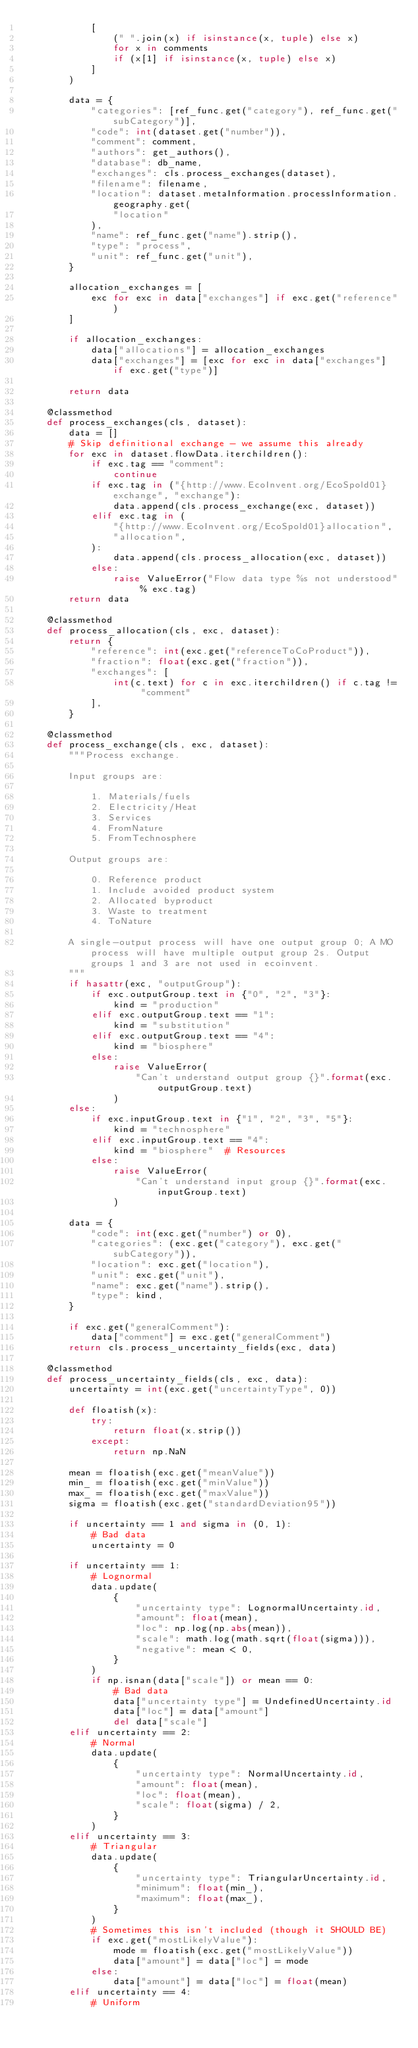Convert code to text. <code><loc_0><loc_0><loc_500><loc_500><_Python_>            [
                (" ".join(x) if isinstance(x, tuple) else x)
                for x in comments
                if (x[1] if isinstance(x, tuple) else x)
            ]
        )

        data = {
            "categories": [ref_func.get("category"), ref_func.get("subCategory")],
            "code": int(dataset.get("number")),
            "comment": comment,
            "authors": get_authors(),
            "database": db_name,
            "exchanges": cls.process_exchanges(dataset),
            "filename": filename,
            "location": dataset.metaInformation.processInformation.geography.get(
                "location"
            ),
            "name": ref_func.get("name").strip(),
            "type": "process",
            "unit": ref_func.get("unit"),
        }

        allocation_exchanges = [
            exc for exc in data["exchanges"] if exc.get("reference")
        ]

        if allocation_exchanges:
            data["allocations"] = allocation_exchanges
            data["exchanges"] = [exc for exc in data["exchanges"] if exc.get("type")]

        return data

    @classmethod
    def process_exchanges(cls, dataset):
        data = []
        # Skip definitional exchange - we assume this already
        for exc in dataset.flowData.iterchildren():
            if exc.tag == "comment":
                continue
            if exc.tag in ("{http://www.EcoInvent.org/EcoSpold01}exchange", "exchange"):
                data.append(cls.process_exchange(exc, dataset))
            elif exc.tag in (
                "{http://www.EcoInvent.org/EcoSpold01}allocation",
                "allocation",
            ):
                data.append(cls.process_allocation(exc, dataset))
            else:
                raise ValueError("Flow data type %s not understood" % exc.tag)
        return data

    @classmethod
    def process_allocation(cls, exc, dataset):
        return {
            "reference": int(exc.get("referenceToCoProduct")),
            "fraction": float(exc.get("fraction")),
            "exchanges": [
                int(c.text) for c in exc.iterchildren() if c.tag != "comment"
            ],
        }

    @classmethod
    def process_exchange(cls, exc, dataset):
        """Process exchange.

        Input groups are:

            1. Materials/fuels
            2. Electricity/Heat
            3. Services
            4. FromNature
            5. FromTechnosphere

        Output groups are:

            0. Reference product
            1. Include avoided product system
            2. Allocated byproduct
            3. Waste to treatment
            4. ToNature

        A single-output process will have one output group 0; A MO process will have multiple output group 2s. Output groups 1 and 3 are not used in ecoinvent.
        """
        if hasattr(exc, "outputGroup"):
            if exc.outputGroup.text in {"0", "2", "3"}:
                kind = "production"
            elif exc.outputGroup.text == "1":
                kind = "substitution"
            elif exc.outputGroup.text == "4":
                kind = "biosphere"
            else:
                raise ValueError(
                    "Can't understand output group {}".format(exc.outputGroup.text)
                )
        else:
            if exc.inputGroup.text in {"1", "2", "3", "5"}:
                kind = "technosphere"
            elif exc.inputGroup.text == "4":
                kind = "biosphere"  # Resources
            else:
                raise ValueError(
                    "Can't understand input group {}".format(exc.inputGroup.text)
                )

        data = {
            "code": int(exc.get("number") or 0),
            "categories": (exc.get("category"), exc.get("subCategory")),
            "location": exc.get("location"),
            "unit": exc.get("unit"),
            "name": exc.get("name").strip(),
            "type": kind,
        }

        if exc.get("generalComment"):
            data["comment"] = exc.get("generalComment")
        return cls.process_uncertainty_fields(exc, data)

    @classmethod
    def process_uncertainty_fields(cls, exc, data):
        uncertainty = int(exc.get("uncertaintyType", 0))

        def floatish(x):
            try:
                return float(x.strip())
            except:
                return np.NaN

        mean = floatish(exc.get("meanValue"))
        min_ = floatish(exc.get("minValue"))
        max_ = floatish(exc.get("maxValue"))
        sigma = floatish(exc.get("standardDeviation95"))

        if uncertainty == 1 and sigma in (0, 1):
            # Bad data
            uncertainty = 0

        if uncertainty == 1:
            # Lognormal
            data.update(
                {
                    "uncertainty type": LognormalUncertainty.id,
                    "amount": float(mean),
                    "loc": np.log(np.abs(mean)),
                    "scale": math.log(math.sqrt(float(sigma))),
                    "negative": mean < 0,
                }
            )
            if np.isnan(data["scale"]) or mean == 0:
                # Bad data
                data["uncertainty type"] = UndefinedUncertainty.id
                data["loc"] = data["amount"]
                del data["scale"]
        elif uncertainty == 2:
            # Normal
            data.update(
                {
                    "uncertainty type": NormalUncertainty.id,
                    "amount": float(mean),
                    "loc": float(mean),
                    "scale": float(sigma) / 2,
                }
            )
        elif uncertainty == 3:
            # Triangular
            data.update(
                {
                    "uncertainty type": TriangularUncertainty.id,
                    "minimum": float(min_),
                    "maximum": float(max_),
                }
            )
            # Sometimes this isn't included (though it SHOULD BE)
            if exc.get("mostLikelyValue"):
                mode = floatish(exc.get("mostLikelyValue"))
                data["amount"] = data["loc"] = mode
            else:
                data["amount"] = data["loc"] = float(mean)
        elif uncertainty == 4:
            # Uniform</code> 